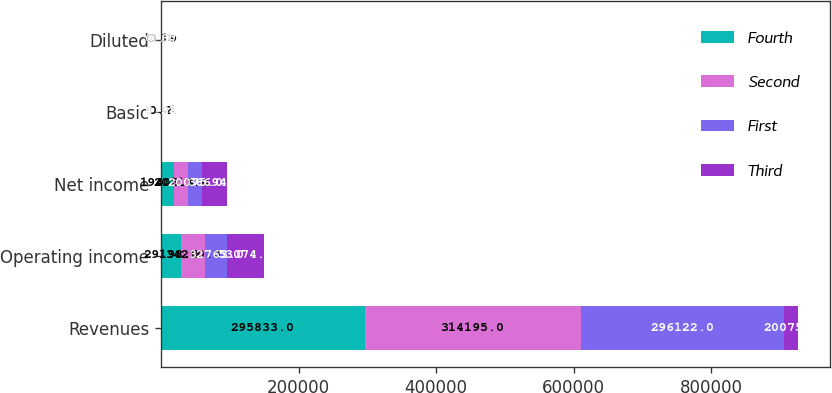<chart> <loc_0><loc_0><loc_500><loc_500><stacked_bar_chart><ecel><fcel>Revenues<fcel>Operating income<fcel>Net income<fcel>Basic<fcel>Diluted<nl><fcel>Fourth<fcel>295833<fcel>29198<fcel>19403<fcel>0.2<fcel>0.19<nl><fcel>Second<fcel>314195<fcel>34230<fcel>20113<fcel>0.21<fcel>0.2<nl><fcel>First<fcel>296122<fcel>32763<fcel>20075<fcel>0.21<fcel>0.2<nl><fcel>Third<fcel>20075<fcel>53074<fcel>36694<fcel>0.38<fcel>0.37<nl></chart> 